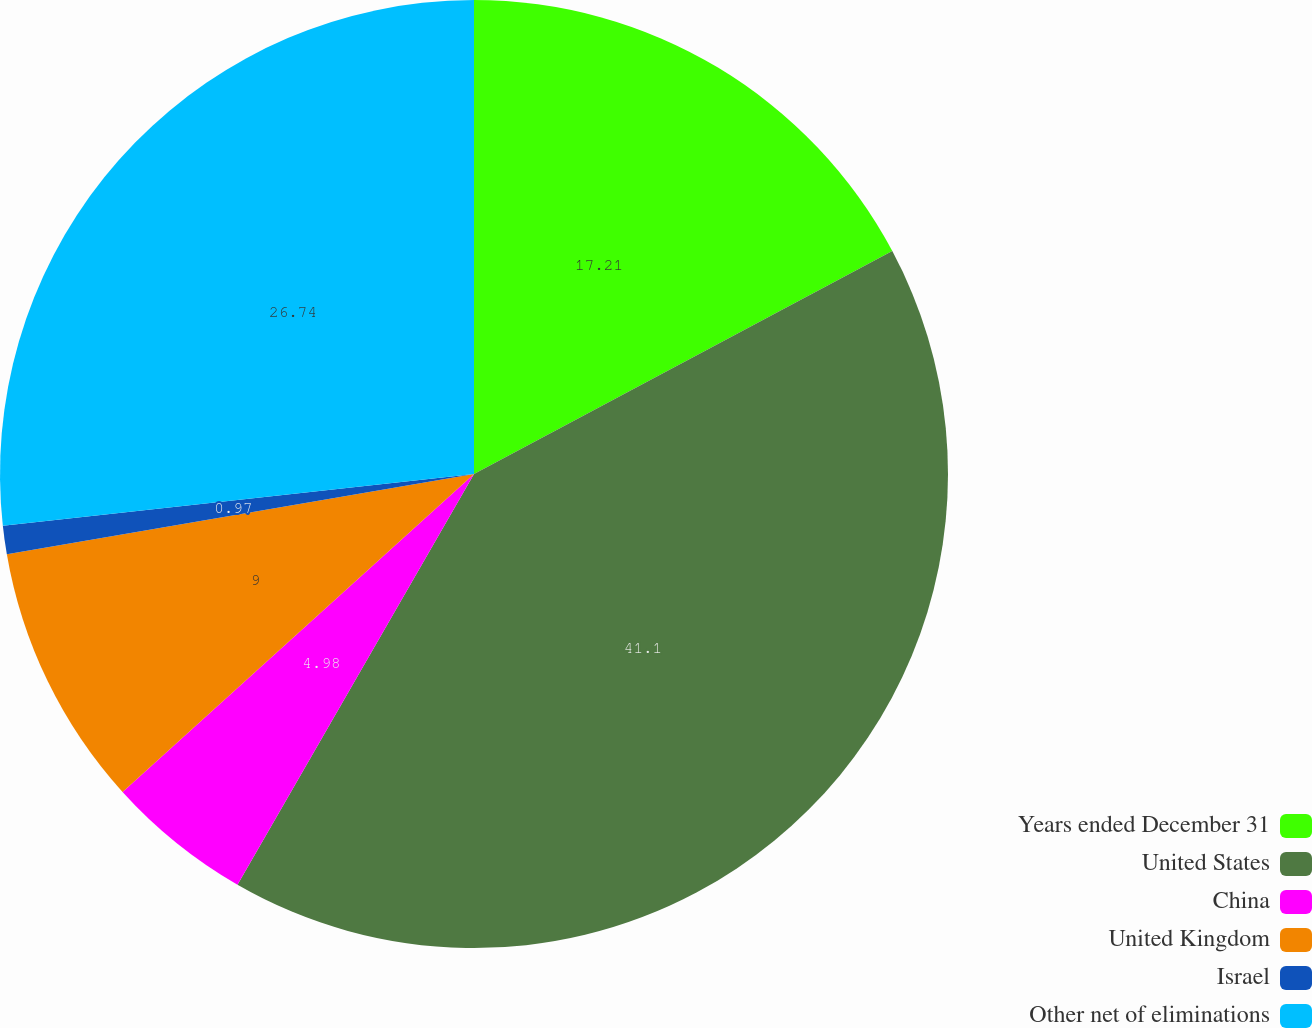Convert chart. <chart><loc_0><loc_0><loc_500><loc_500><pie_chart><fcel>Years ended December 31<fcel>United States<fcel>China<fcel>United Kingdom<fcel>Israel<fcel>Other net of eliminations<nl><fcel>17.21%<fcel>41.11%<fcel>4.98%<fcel>9.0%<fcel>0.97%<fcel>26.74%<nl></chart> 